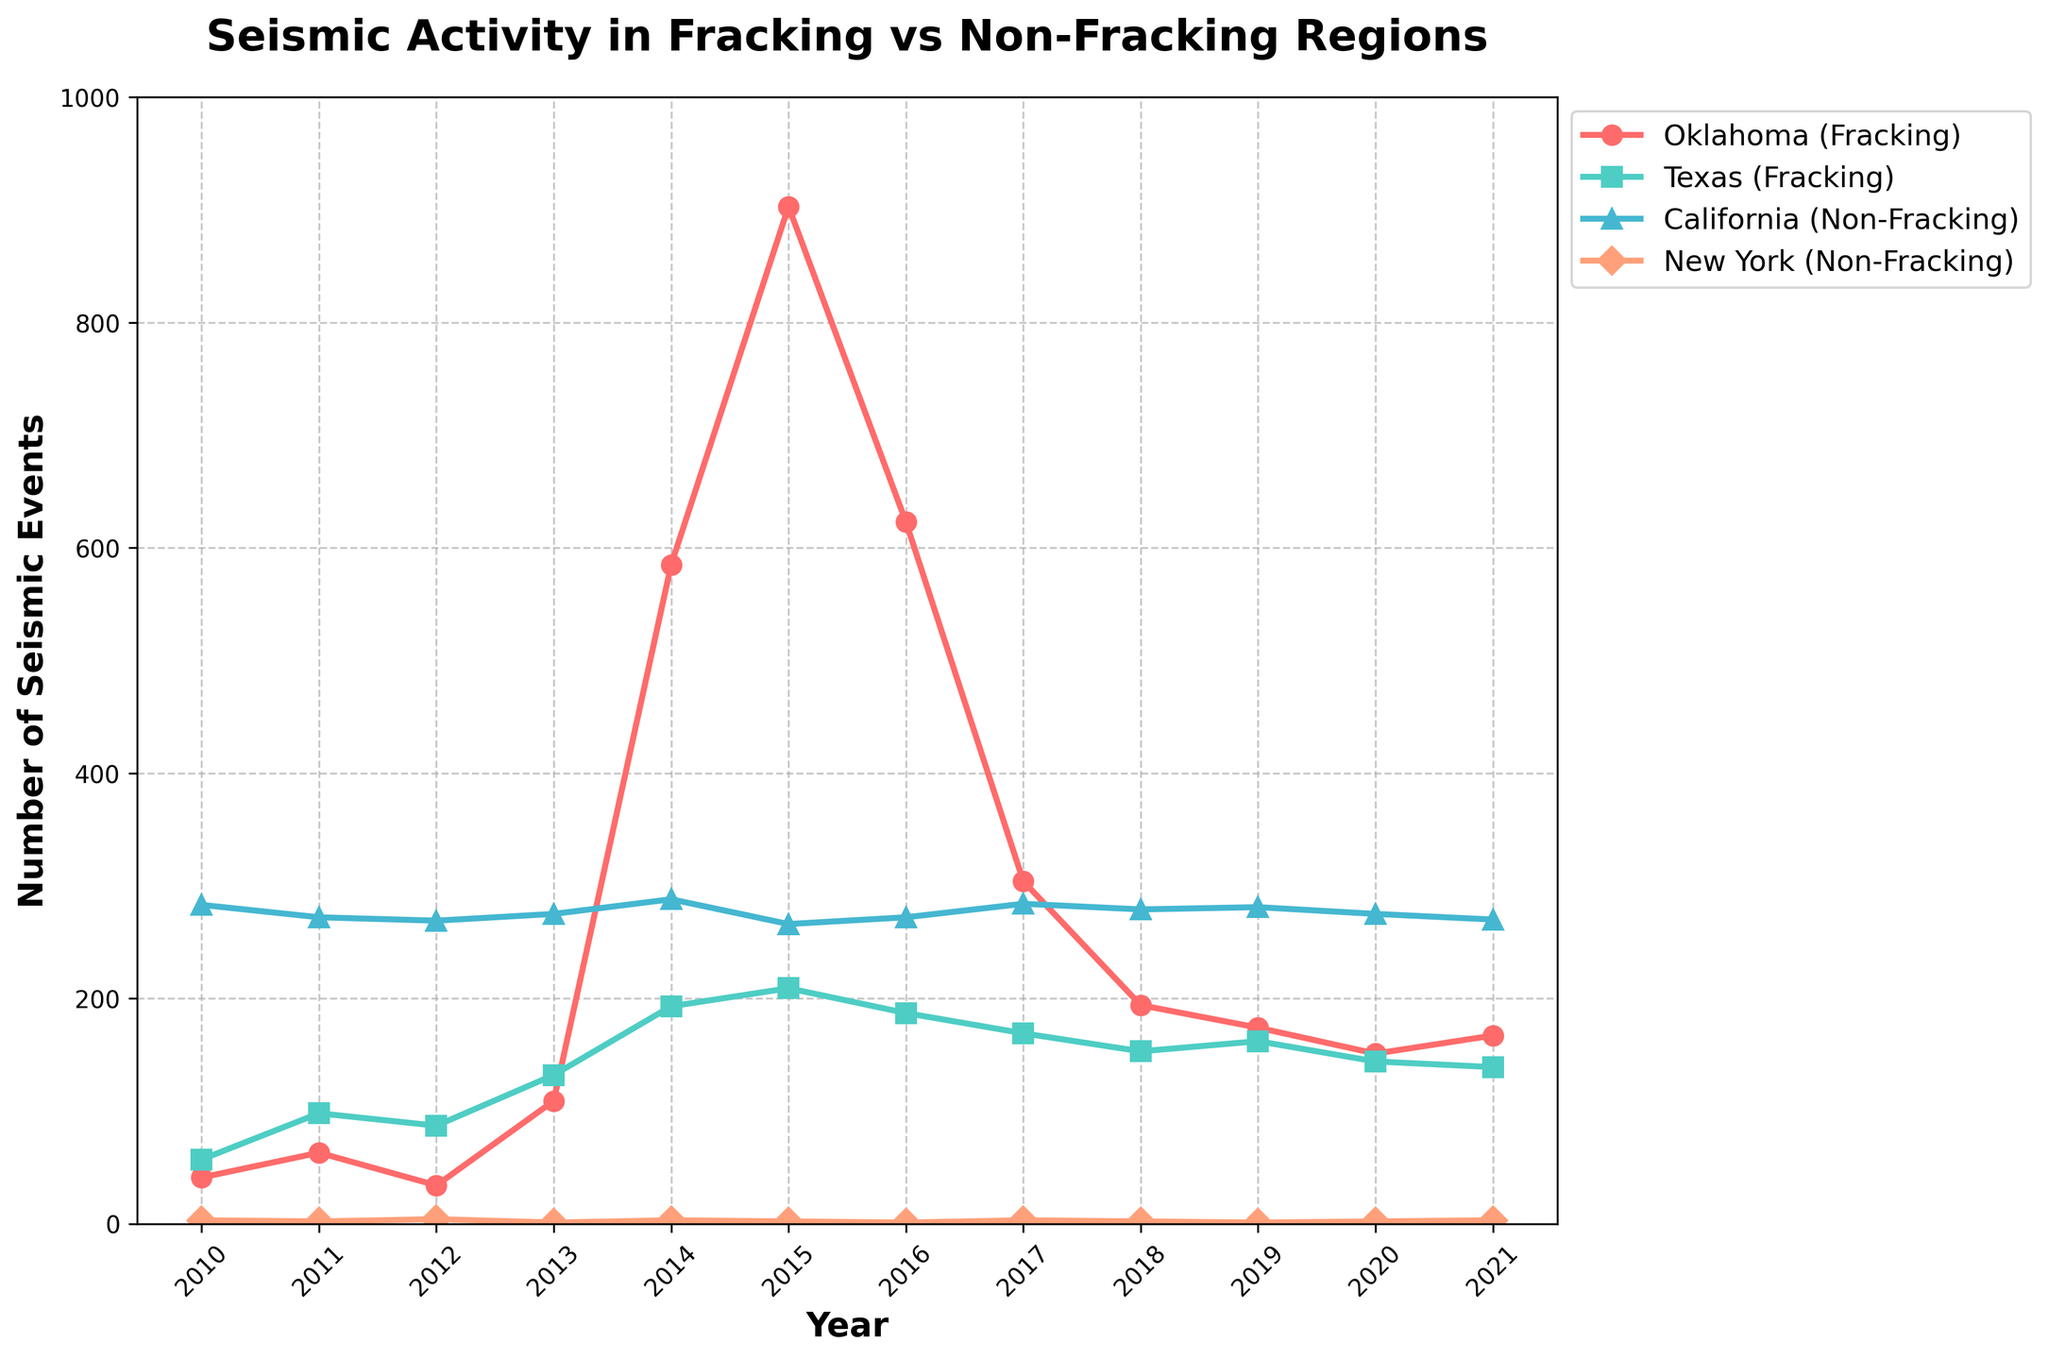What is the trend in the number of seismic events in Oklahoma (Fracking) from 2010 to 2021? According to the line chart, Oklahoma shows an increase in seismic events starting from 2010, peaking in 2015, and then experiencing a decrease from 2016 onwards.
Answer: Increase until 2015, then decrease Which region experienced the highest number of seismic events in any single year, and what is the number? The line chart shows that Oklahoma (Fracking) experienced the highest number of seismic events in 2015, with a count of 903 events.
Answer: Oklahoma in 2015, 903 events How do the seismic event trends in Texas (Fracking) and California (Non-Fracking) compare over the years? Both Texas (Fracking) and California (Non-Fracking) show relative stability in the number of seismic events over the years, but California has consistently higher numbers. Texas shows minor fluctuations with a peak in 2014 and 2015, while California remains relatively constant.
Answer: California consistently higher, both relatively stable What is the average number of seismic events in New York (Non-Fracking) from 2010 to 2021? Sum the number of seismic events in New York (Non-Fracking) for all years: 3 + 2 + 4 + 1 + 3 + 2 + 1 + 3 + 2 + 1 + 2 + 3 = 27. Divide by the number of years, which is 12. 27/12 = 2.25.
Answer: 2.25 Which region shows the most significant change in the number of seismic events over the years, and is this an increase or a decrease? The line chart shows Oklahoma (Fracking) with the most significant change. It increased dramatically from 2010 (41 events) to 2015 (903 events) and then decreased to 167 events in 2021.
Answer: Oklahoma, increase then decrease In which year did Oklahoma (Fracking) and Texas (Fracking) have the closest number of seismic events, and what were the respective counts? According to the line chart, in 2019, Oklahoma (Fracking) had 174 events, and Texas (Fracking) had 162 events, making it the year with the closest counts.
Answer: 2019, Oklahoma: 174, Texas: 162 What is the difference in the number of seismic events between California (Non-Fracking) and New York (Non-Fracking) in 2021? According to the line chart, California (Non-Fracking) had 270 events in 2021, and New York (Non-Fracking) had 3 events. The difference is 270 - 3 = 267.
Answer: 267 Which region had the most stable seismic activity from 2010 to 2021, considering both fracking and non-fracking areas? According to the line chart, New York (Non-Fracking) had the most stable seismic activity, with counts remaining consistently low and showing minimal fluctuation over the years.
Answer: New York Do fracking regions generally have higher seismic activity compared to non-fracking regions based on the chart? The line chart shows that fracking regions (Oklahoma and Texas) generally have higher seismic activity compared to non-fracking regions (California and New York).
Answer: Yes What was the trend in seismic activity in California (Non-Fracking) over the observed years? According to the line chart, California (Non-Fracking) shows a relatively stable trend in seismic activity with minor fluctuations, staying around the high 260s to high 280s.
Answer: Relatively stable 